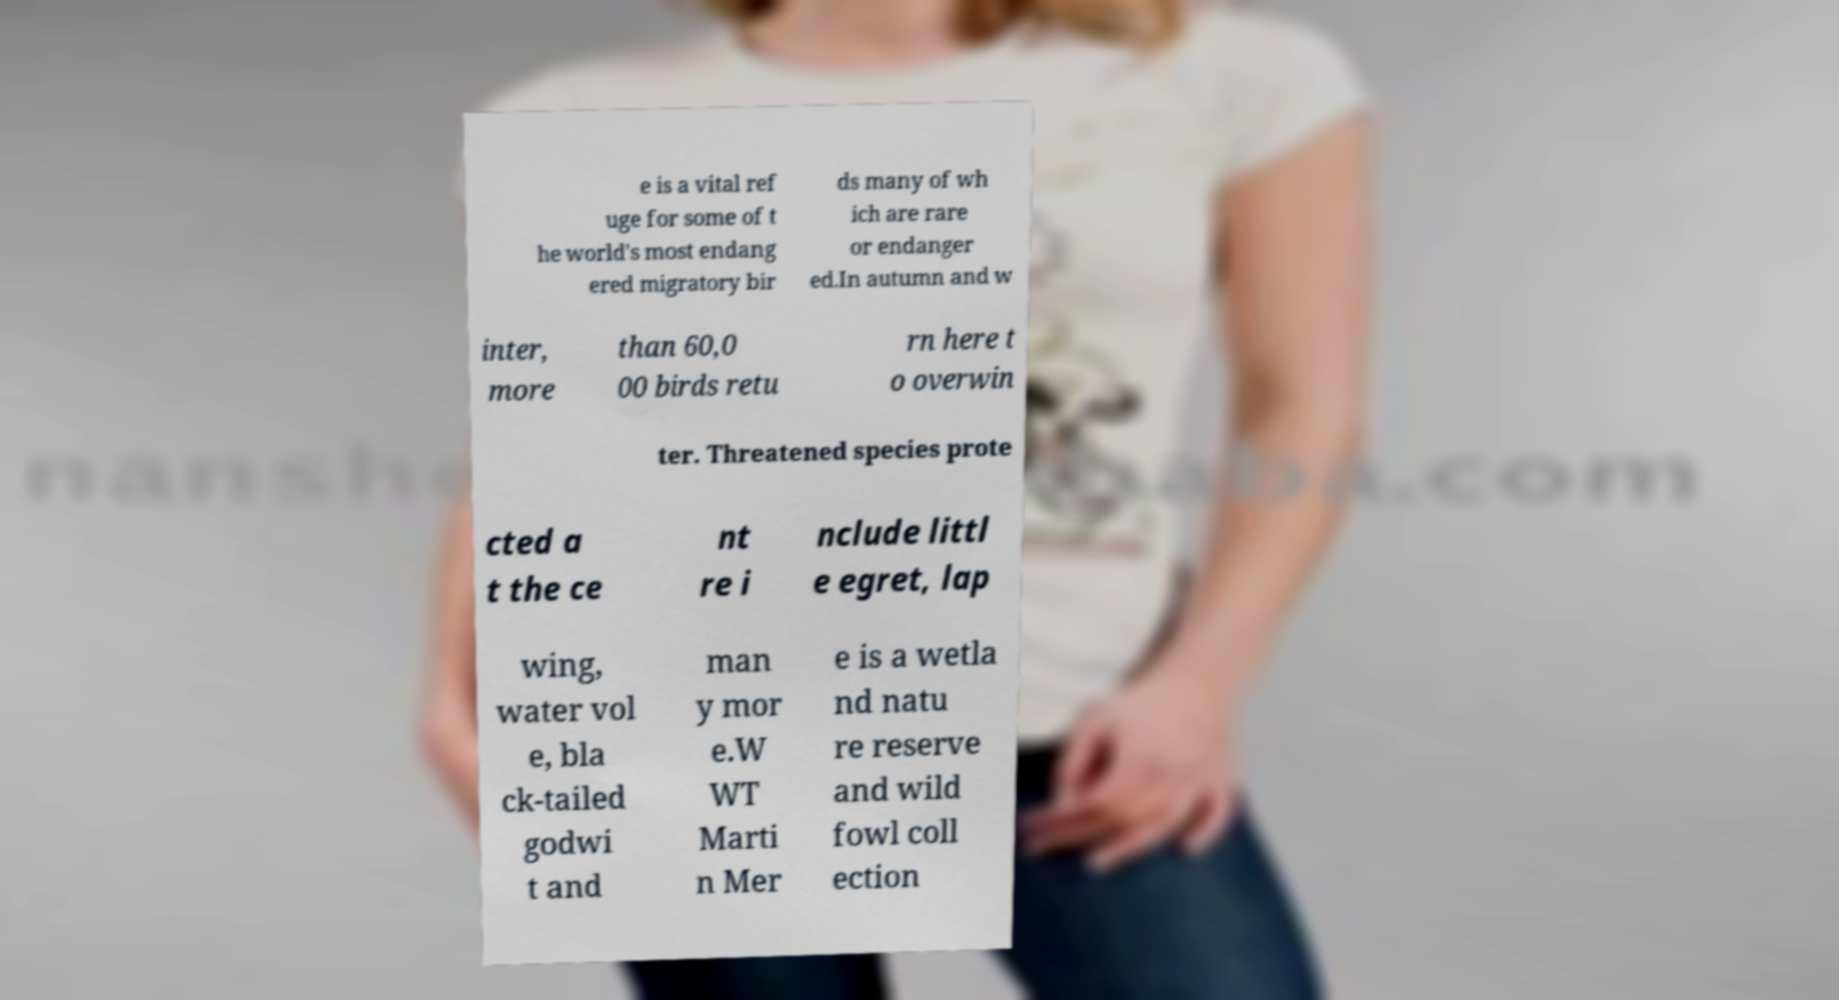Can you accurately transcribe the text from the provided image for me? e is a vital ref uge for some of t he world's most endang ered migratory bir ds many of wh ich are rare or endanger ed.In autumn and w inter, more than 60,0 00 birds retu rn here t o overwin ter. Threatened species prote cted a t the ce nt re i nclude littl e egret, lap wing, water vol e, bla ck-tailed godwi t and man y mor e.W WT Marti n Mer e is a wetla nd natu re reserve and wild fowl coll ection 